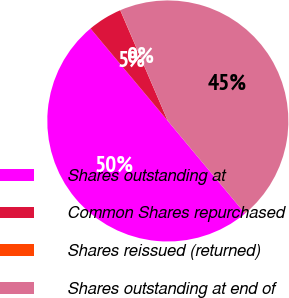<chart> <loc_0><loc_0><loc_500><loc_500><pie_chart><fcel>Shares outstanding at<fcel>Common Shares repurchased<fcel>Shares reissued (returned)<fcel>Shares outstanding at end of<nl><fcel>49.98%<fcel>4.62%<fcel>0.02%<fcel>45.38%<nl></chart> 